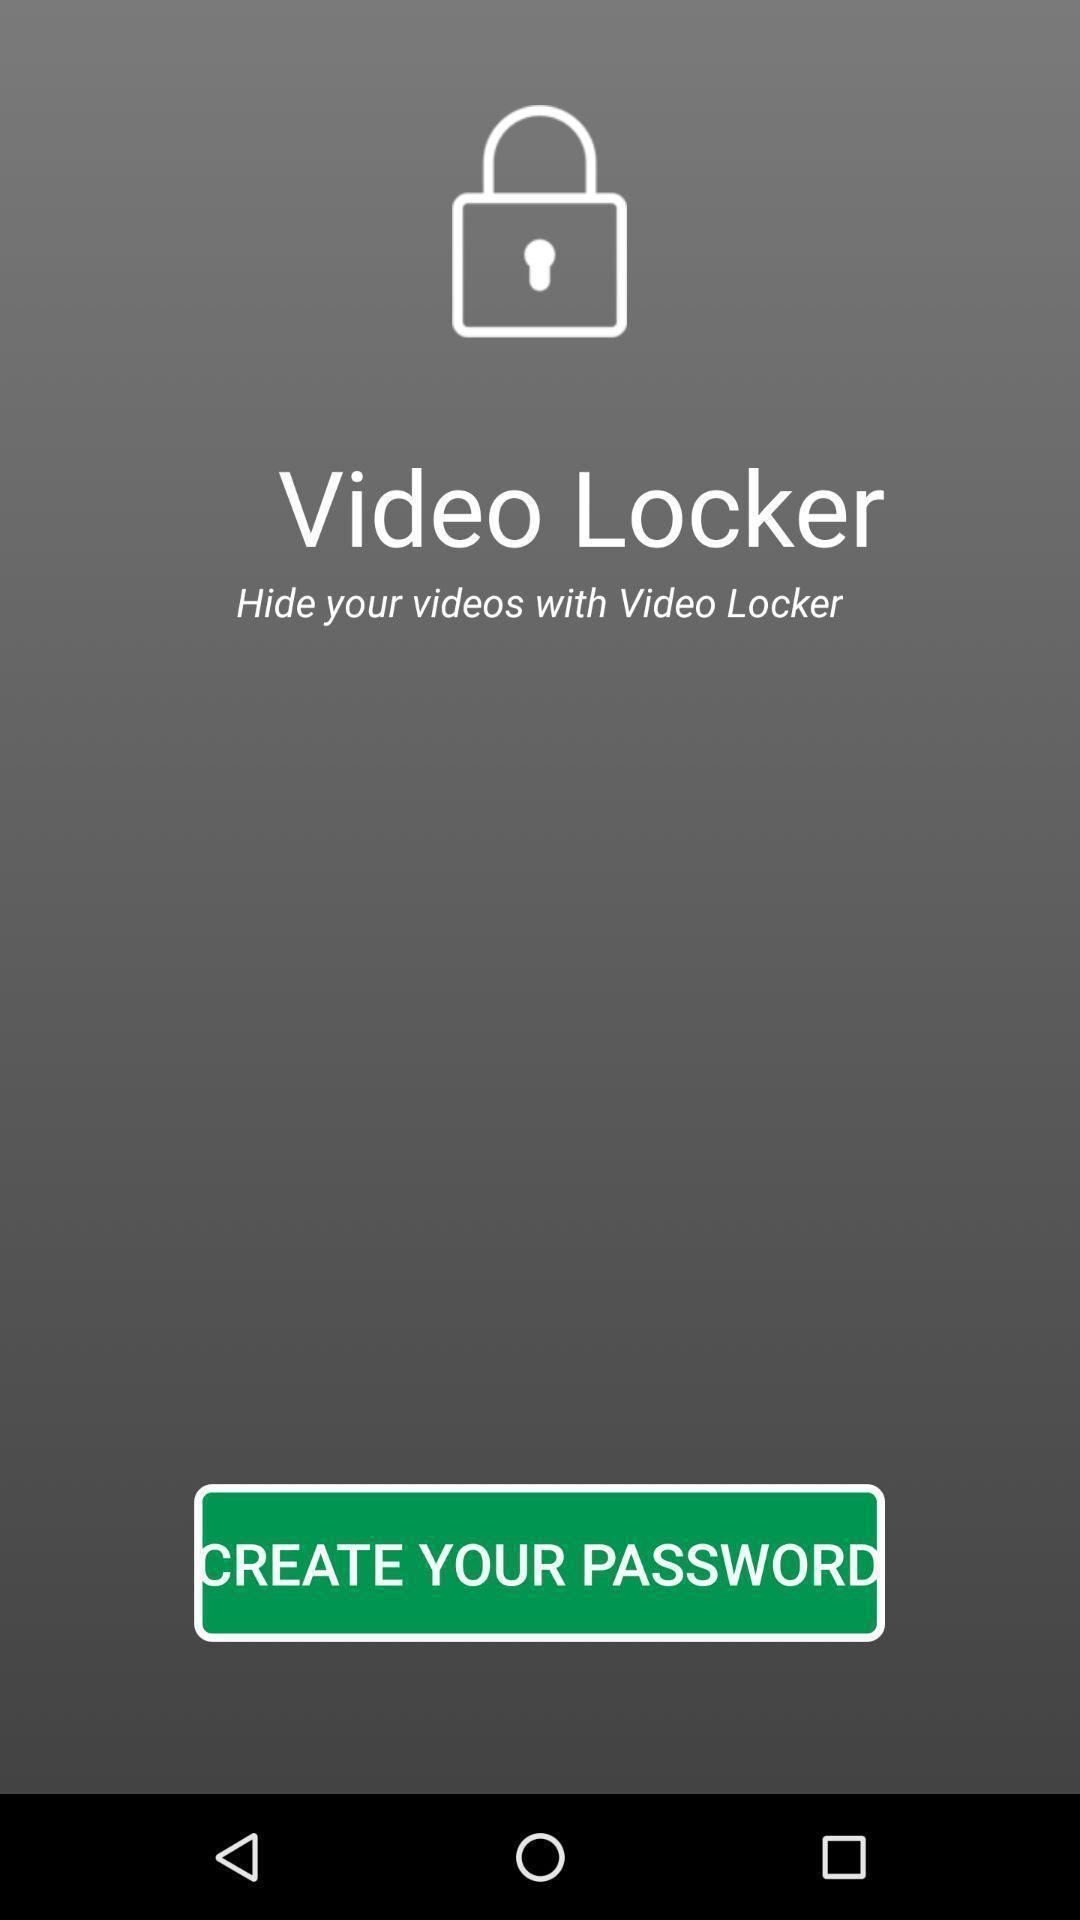Summarize the information in this screenshot. Page requesting to create the password on an app. 